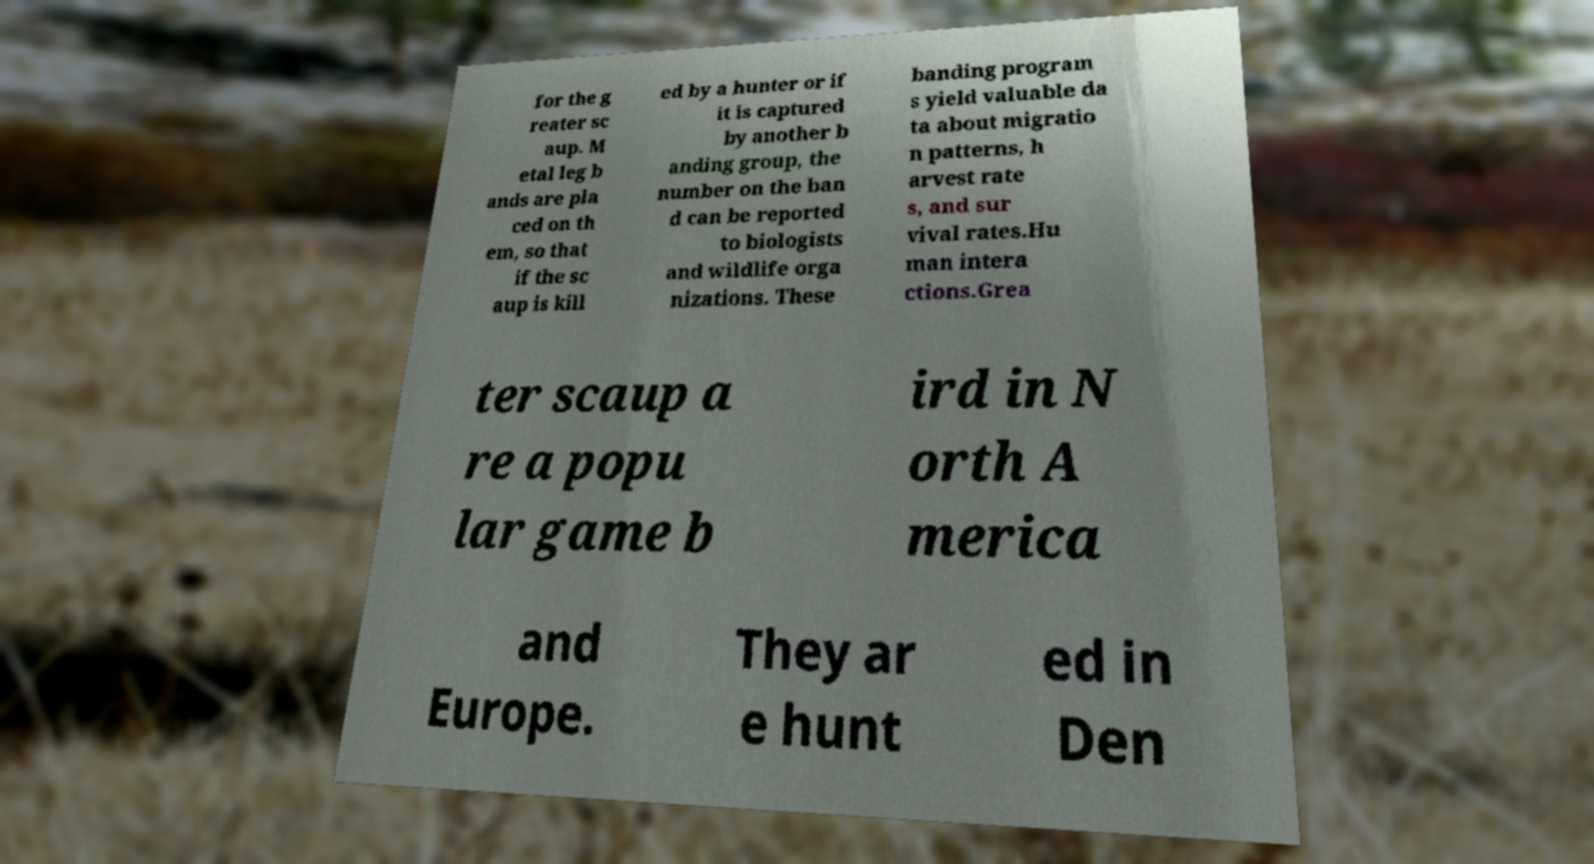Please read and relay the text visible in this image. What does it say? for the g reater sc aup. M etal leg b ands are pla ced on th em, so that if the sc aup is kill ed by a hunter or if it is captured by another b anding group, the number on the ban d can be reported to biologists and wildlife orga nizations. These banding program s yield valuable da ta about migratio n patterns, h arvest rate s, and sur vival rates.Hu man intera ctions.Grea ter scaup a re a popu lar game b ird in N orth A merica and Europe. They ar e hunt ed in Den 